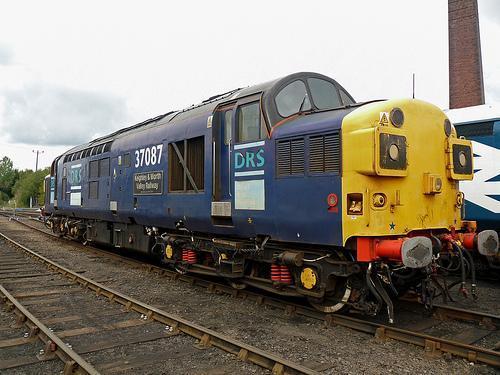How many green trains are there?
Give a very brief answer. 0. 